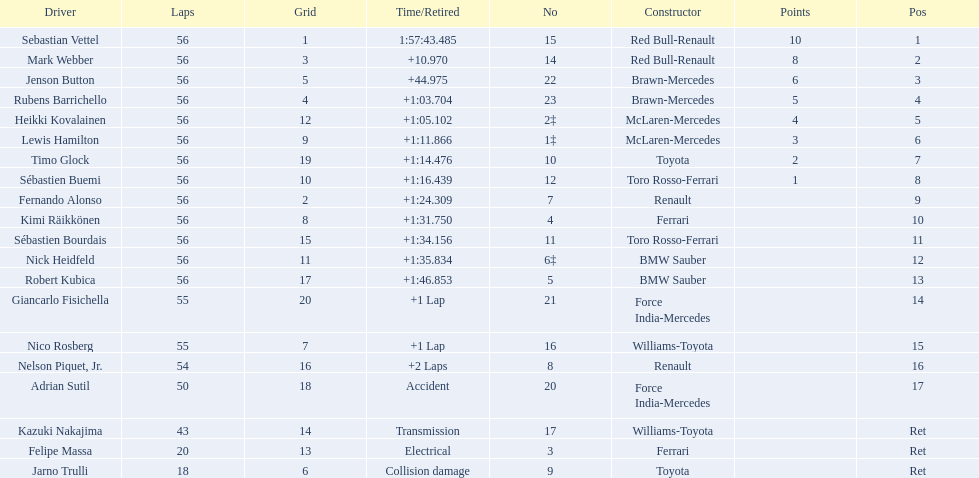Who are all of the drivers? Sebastian Vettel, Mark Webber, Jenson Button, Rubens Barrichello, Heikki Kovalainen, Lewis Hamilton, Timo Glock, Sébastien Buemi, Fernando Alonso, Kimi Räikkönen, Sébastien Bourdais, Nick Heidfeld, Robert Kubica, Giancarlo Fisichella, Nico Rosberg, Nelson Piquet, Jr., Adrian Sutil, Kazuki Nakajima, Felipe Massa, Jarno Trulli. Who were their constructors? Red Bull-Renault, Red Bull-Renault, Brawn-Mercedes, Brawn-Mercedes, McLaren-Mercedes, McLaren-Mercedes, Toyota, Toro Rosso-Ferrari, Renault, Ferrari, Toro Rosso-Ferrari, BMW Sauber, BMW Sauber, Force India-Mercedes, Williams-Toyota, Renault, Force India-Mercedes, Williams-Toyota, Ferrari, Toyota. Who was the first listed driver to not drive a ferrari?? Sebastian Vettel. 